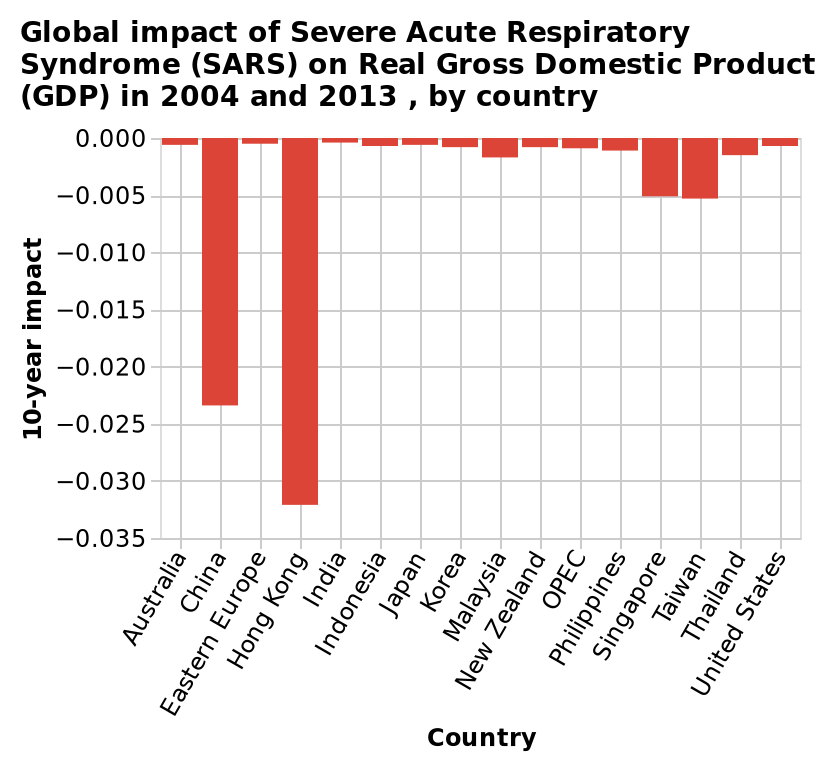<image>
What does the bar diagram represent? The bar diagram represents the global impact of Severe Acute Respiratory Syndrome (SARS) on Real Gross Domestic Product (GDP) in 2004 and 2013, categorized by country. What is the name of the bar diagram?  The bar diagram is named "Global impact of Severe Acute Respiratory Syndrome (SARS) on Real Gross Domestic Product (GDP) in 2004 and 2013, by country." What is measured on the x-axis of the bar diagram?  The x-axis of the bar diagram measures the countries impacted by Severe Acute Respiratory Syndrome (SARS) in 2004 and 2013. Was SARS more impactful in Hong Kong or China between 2004 and 2013? Both Hong Kong and China were equally impacted by SARS between 2004 and 2013. Can you provide any specific data on the level of impact in Hong Kong and China during the SARS outbreak from 2004 to 2013? The description does not provide specific data on the level of impact in Hong Kong and China during the SARS outbreak from 2004 to 2013. Is the bar diagram named "Local impact of Mild Chronic Respiratory Syndrome (MCRS) on Nominal Gross Domestic Product (GDP) in 2004 and 2013, by city"? No. The bar diagram is named "Global impact of Severe Acute Respiratory Syndrome (SARS) on Real Gross Domestic Product (GDP) in 2004 and 2013, by country." 